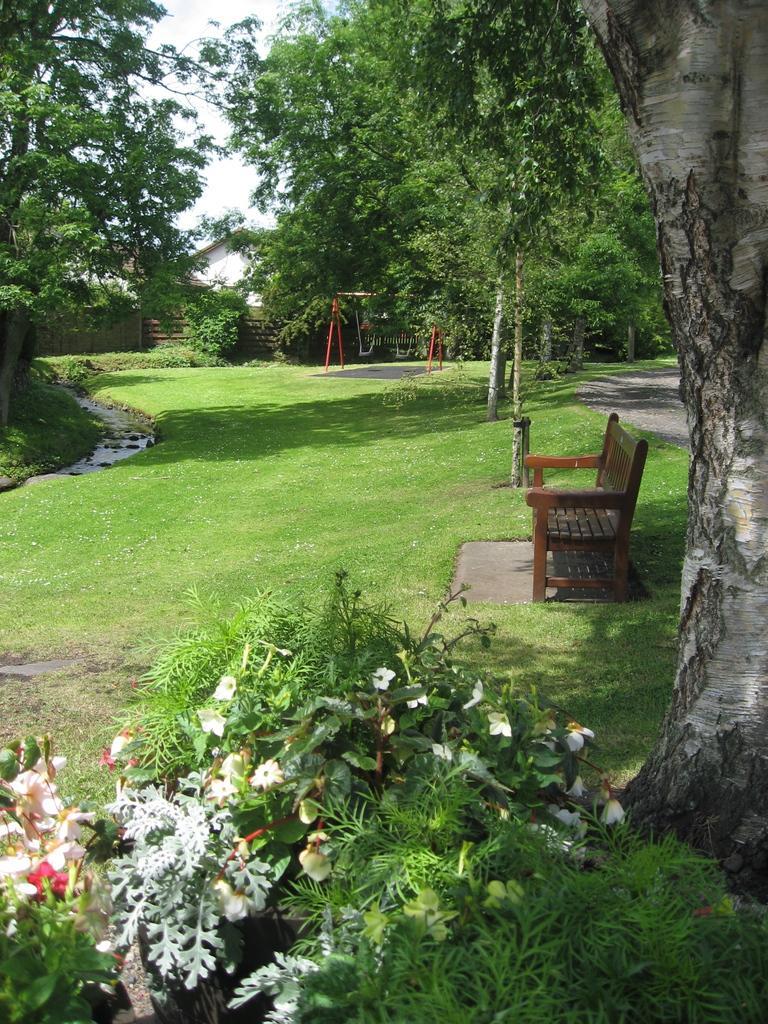How would you summarize this image in a sentence or two? In this image there is a bench in the garden there are some plants with flowers ,leaves and at the back ground there are tree and a u shaped swing in the garden , and a house and a sky. 